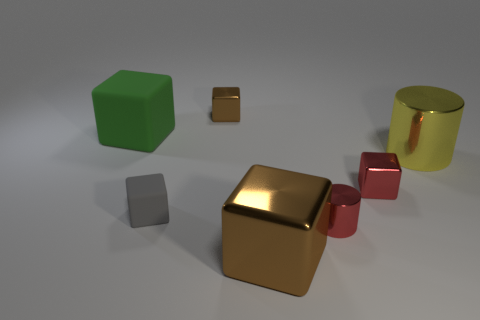What is the material of the big green thing?
Your answer should be very brief. Rubber. What color is the large metal cylinder?
Your answer should be very brief. Yellow. The large object that is in front of the big rubber object and behind the gray rubber object is what color?
Give a very brief answer. Yellow. Are the gray cube and the large cube to the left of the large shiny cube made of the same material?
Your response must be concise. Yes. What is the size of the brown cube right of the tiny object behind the yellow cylinder?
Provide a succinct answer. Large. Are there any other things that have the same color as the tiny cylinder?
Offer a terse response. Yes. Do the big block that is in front of the large metallic cylinder and the large yellow cylinder behind the tiny gray thing have the same material?
Provide a succinct answer. Yes. What material is the object that is to the left of the tiny brown metallic cube and behind the small gray thing?
Make the answer very short. Rubber. Does the green thing have the same shape as the yellow metallic thing that is right of the red metal cylinder?
Your response must be concise. No. The small gray cube that is to the left of the brown thing behind the brown shiny object that is in front of the yellow shiny cylinder is made of what material?
Your response must be concise. Rubber. 